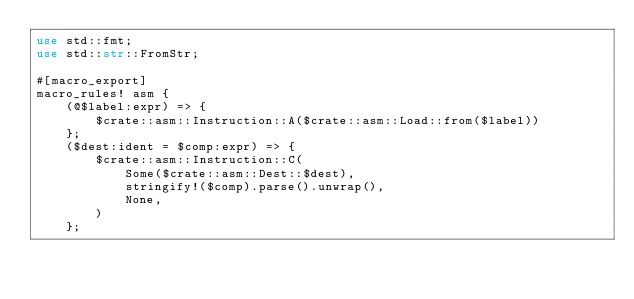Convert code to text. <code><loc_0><loc_0><loc_500><loc_500><_Rust_>use std::fmt;
use std::str::FromStr;

#[macro_export]
macro_rules! asm {
    (@$label:expr) => {
        $crate::asm::Instruction::A($crate::asm::Load::from($label))
    };
    ($dest:ident = $comp:expr) => {
        $crate::asm::Instruction::C(
            Some($crate::asm::Dest::$dest),
            stringify!($comp).parse().unwrap(),
            None,
        )
    };</code> 